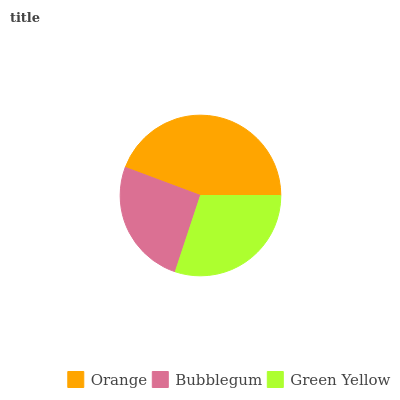Is Bubblegum the minimum?
Answer yes or no. Yes. Is Orange the maximum?
Answer yes or no. Yes. Is Green Yellow the minimum?
Answer yes or no. No. Is Green Yellow the maximum?
Answer yes or no. No. Is Green Yellow greater than Bubblegum?
Answer yes or no. Yes. Is Bubblegum less than Green Yellow?
Answer yes or no. Yes. Is Bubblegum greater than Green Yellow?
Answer yes or no. No. Is Green Yellow less than Bubblegum?
Answer yes or no. No. Is Green Yellow the high median?
Answer yes or no. Yes. Is Green Yellow the low median?
Answer yes or no. Yes. Is Orange the high median?
Answer yes or no. No. Is Bubblegum the low median?
Answer yes or no. No. 